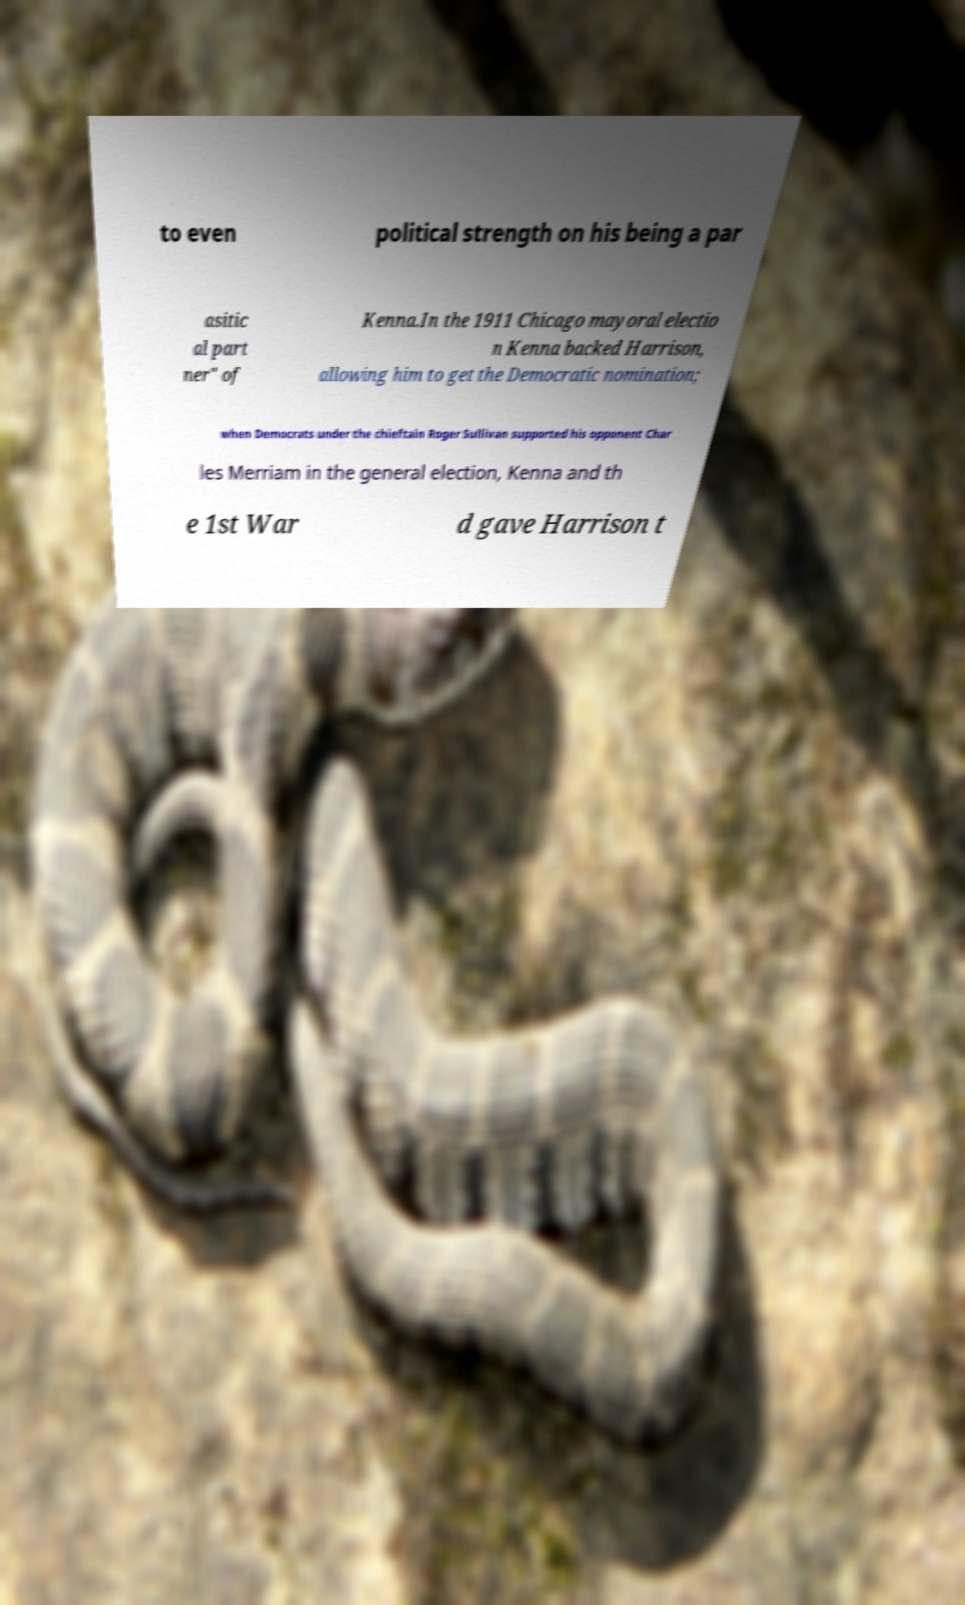For documentation purposes, I need the text within this image transcribed. Could you provide that? to even political strength on his being a par asitic al part ner" of Kenna.In the 1911 Chicago mayoral electio n Kenna backed Harrison, allowing him to get the Democratic nomination; when Democrats under the chieftain Roger Sullivan supported his opponent Char les Merriam in the general election, Kenna and th e 1st War d gave Harrison t 